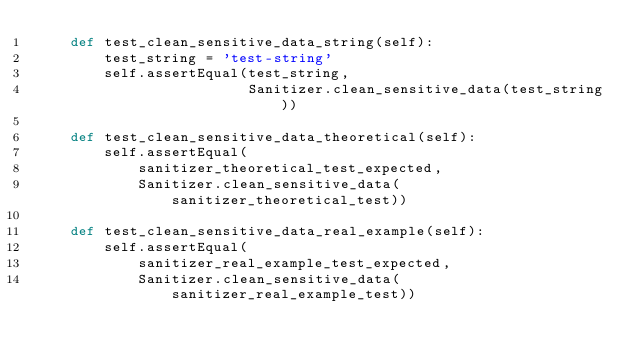Convert code to text. <code><loc_0><loc_0><loc_500><loc_500><_Python_>    def test_clean_sensitive_data_string(self):
        test_string = 'test-string'
        self.assertEqual(test_string,
                         Sanitizer.clean_sensitive_data(test_string))

    def test_clean_sensitive_data_theoretical(self):
        self.assertEqual(
            sanitizer_theoretical_test_expected,
            Sanitizer.clean_sensitive_data(sanitizer_theoretical_test))

    def test_clean_sensitive_data_real_example(self):
        self.assertEqual(
            sanitizer_real_example_test_expected,
            Sanitizer.clean_sensitive_data(sanitizer_real_example_test))
</code> 